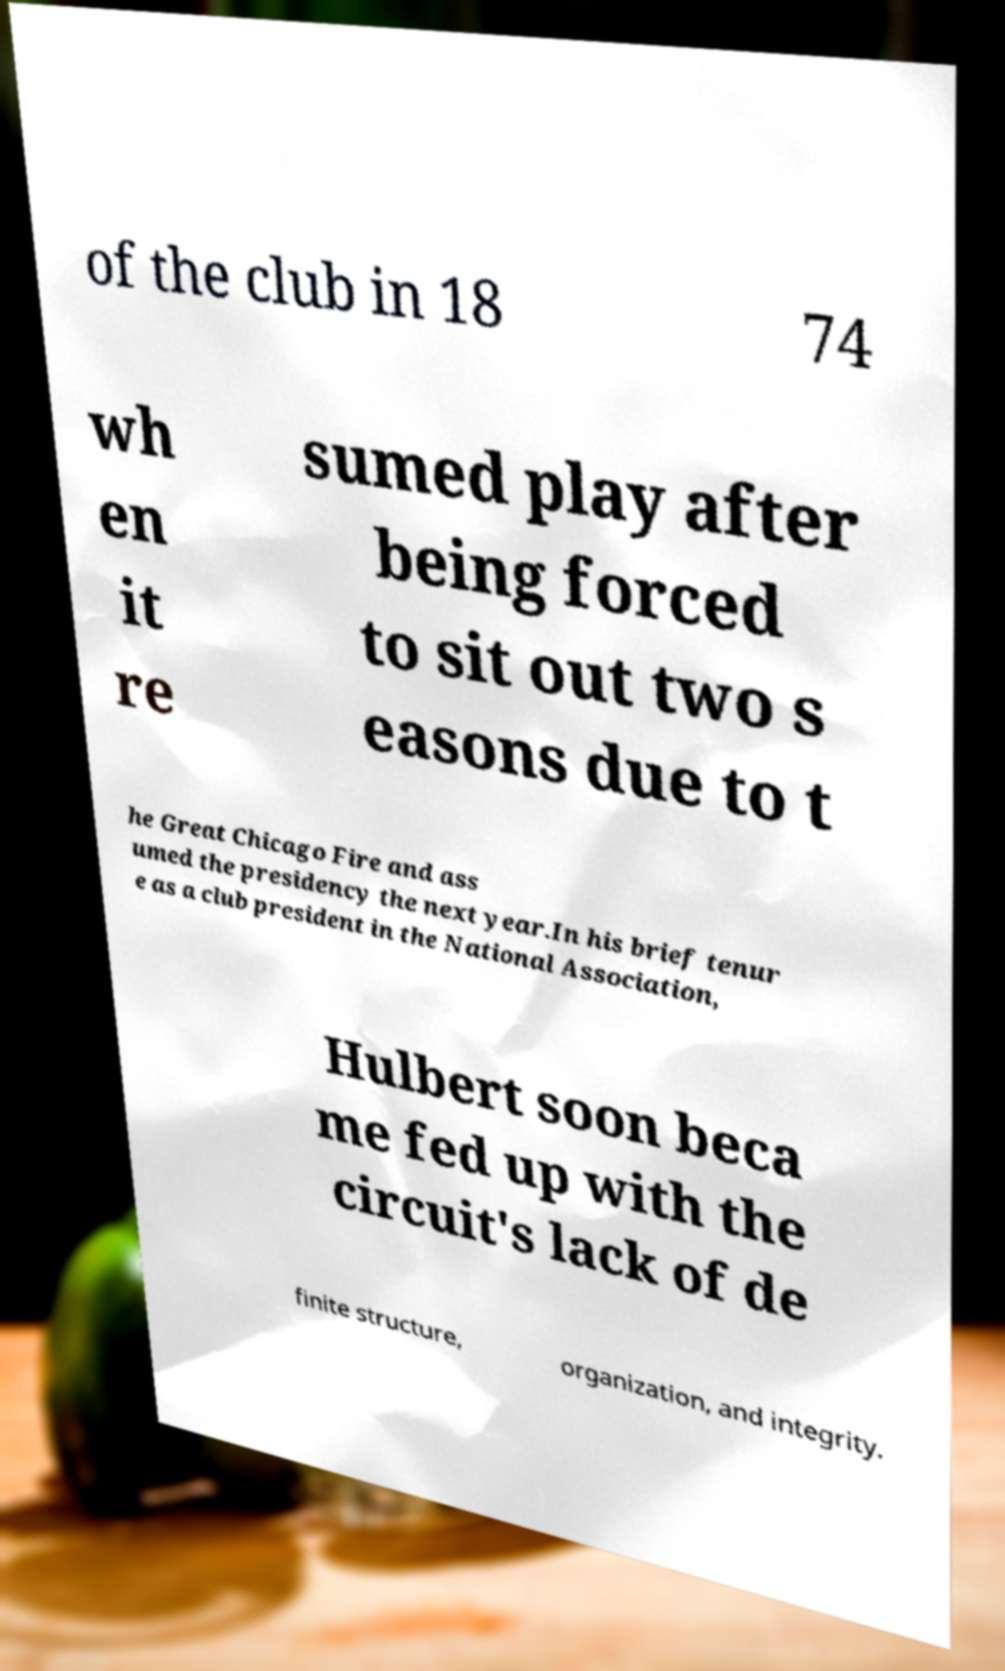Could you extract and type out the text from this image? of the club in 18 74 wh en it re sumed play after being forced to sit out two s easons due to t he Great Chicago Fire and ass umed the presidency the next year.In his brief tenur e as a club president in the National Association, Hulbert soon beca me fed up with the circuit's lack of de finite structure, organization, and integrity. 